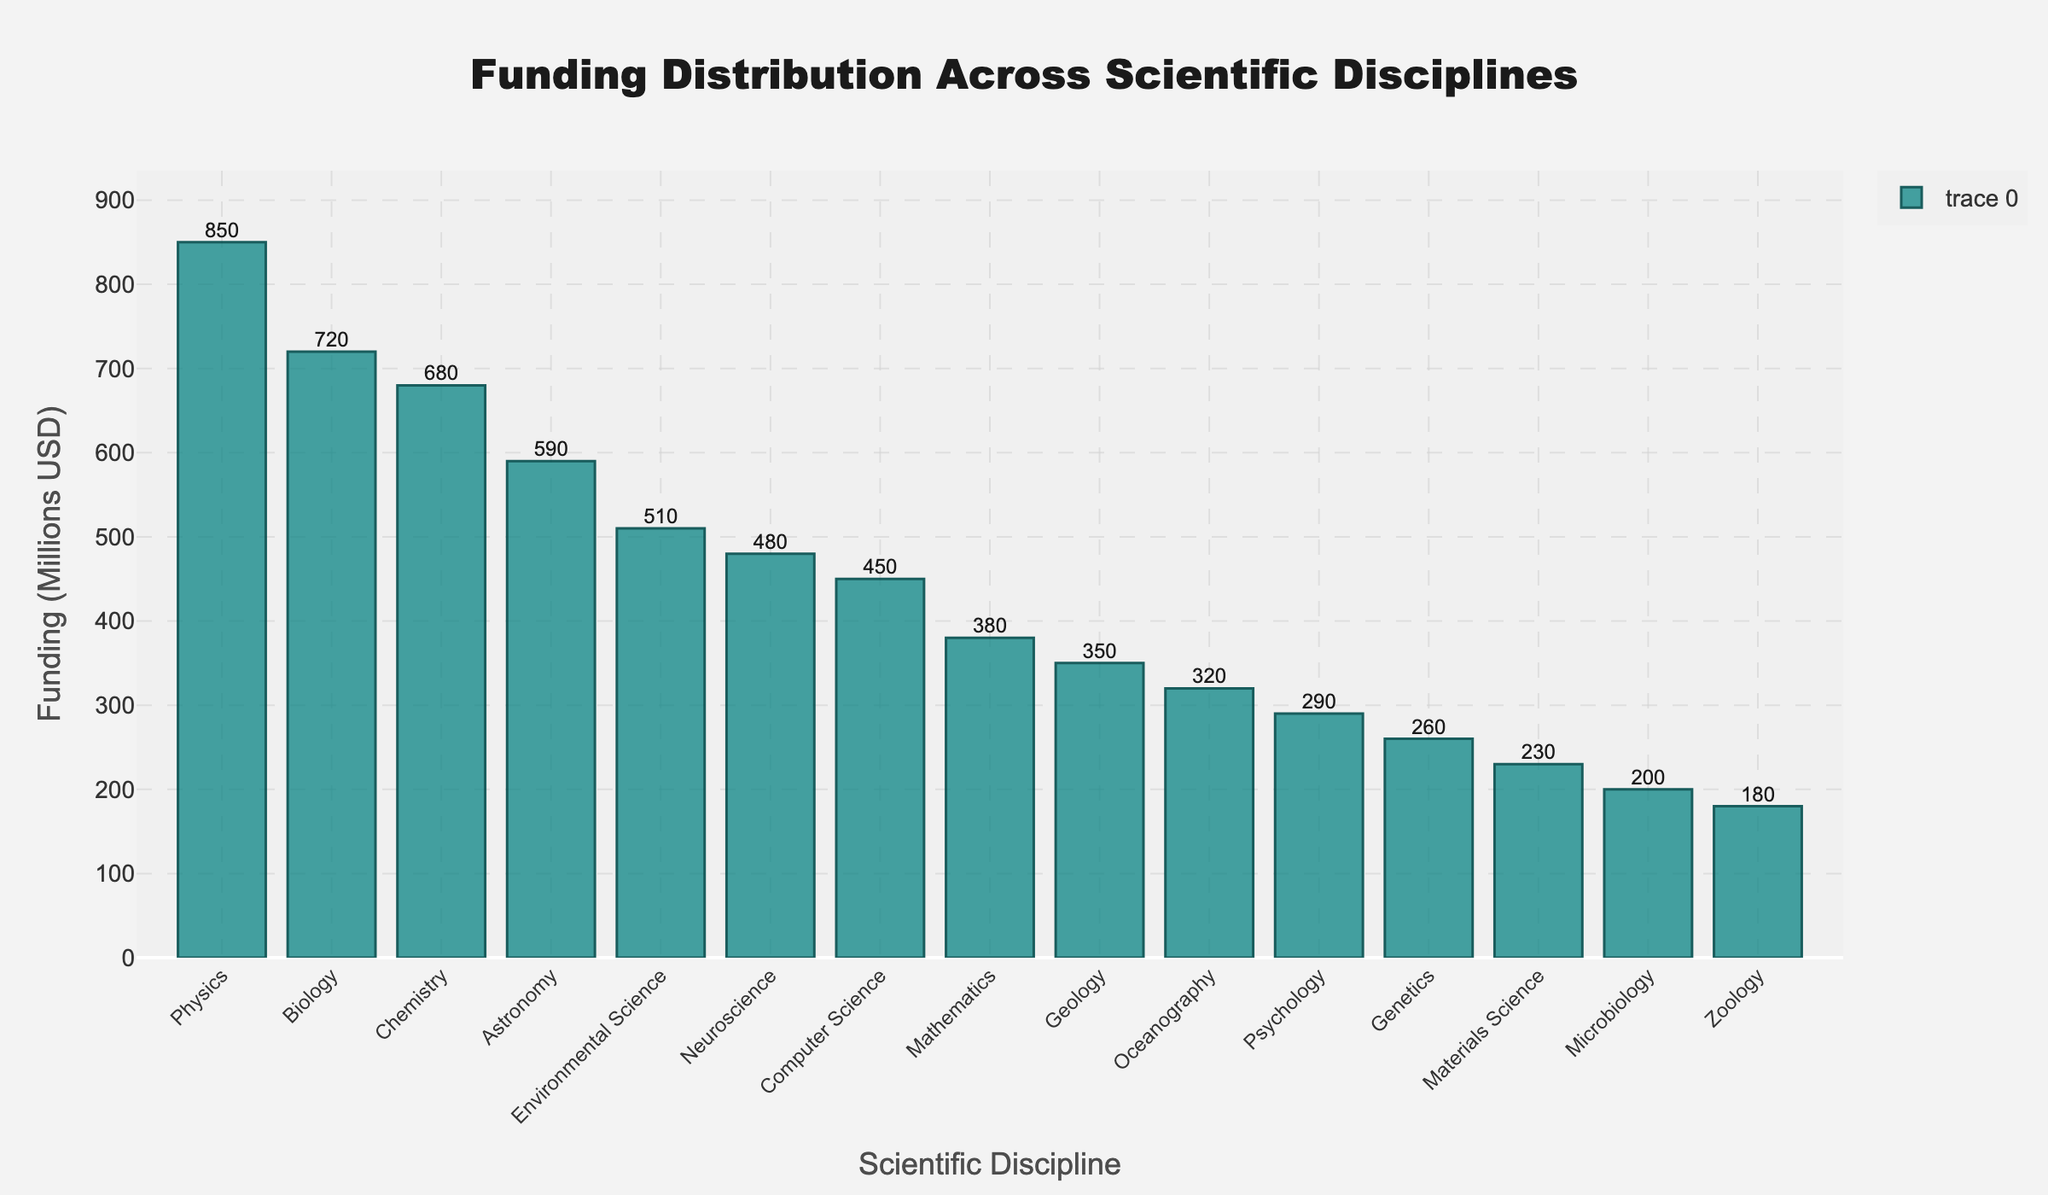What is the total funding for Physics and Biology? To find the total funding for Physics and Biology, add the funding values for each: 850 + 720 = 1570 million USD.
Answer: 1570 million USD Which discipline received the least funding? By looking at the bar heights (or the values), Zoology has the smallest bar and the value next to it is the lowest, indicating the least funding.
Answer: Zoology What's the difference in funding between Astronomy and Oceanography? Subtract the funding for Oceanography from that of Astronomy: 590 - 320 = 270 million USD.
Answer: 270 million USD Which discipline received more funding: Chemistry or Environmental Science? By comparing the bar heights and their values, Chemistry received 680 million USD while Environmental Science received 510 million USD. Chemistry received more funding.
Answer: Chemistry How much more funding did Physics receive compared to Computer Science? Subtract the funding for Computer Science from Physics: 850 - 450 = 400 million USD.
Answer: 400 million USD Rank the top three disciplines in terms of funding. By looking at the bar heights and their corresponding values, the top three disciplines are Physics (850 million USD), Biology (720 million USD), and Chemistry (680 million USD).
Answer: Physics, Biology, Chemistry What's the total funding for Neuroscience, Computer Science, and Mathematics combined? Add the funding amounts for Neuroscience, Computer Science, and Mathematics: 480 + 450 + 380 = 1310 million USD.
Answer: 1310 million USD If the funding for Psychology were doubled, how would it compare to that of Genetics? Double the funding for Psychology: 290 * 2 = 580. Compare this with Genetics' funding of 260 million USD. 580 is greater than 260, so it would be higher.
Answer: Higher Identify disciplines whose funding is below 300 million USD. By examining bar heights and the values, disciplines with funding below 300 million USD are Psychology (290), Genetics (260), Materials Science (230), Microbiology (200), and Zoology (180).
Answer: Psychology, Genetics, Materials Science, Microbiology, Zoology Which discipline has a funding amount closest to Chemistry? Compare the funding amounts to Chemistry's 680 million USD. Biology has a funding amount of 720 million USD, which is the closest.
Answer: Biology 